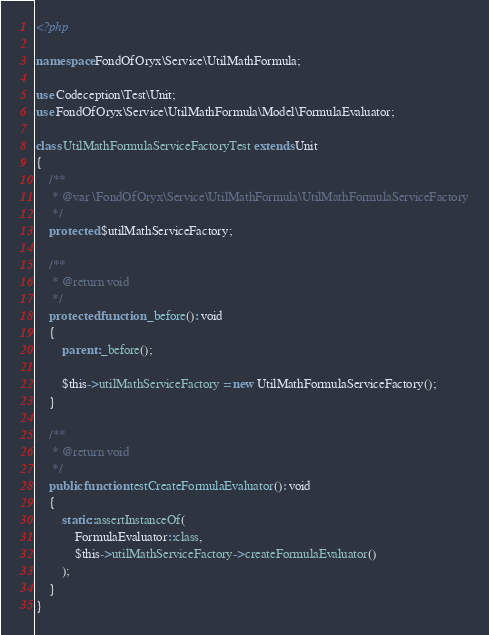Convert code to text. <code><loc_0><loc_0><loc_500><loc_500><_PHP_><?php

namespace FondOfOryx\Service\UtilMathFormula;

use Codeception\Test\Unit;
use FondOfOryx\Service\UtilMathFormula\Model\FormulaEvaluator;

class UtilMathFormulaServiceFactoryTest extends Unit
{
    /**
     * @var \FondOfOryx\Service\UtilMathFormula\UtilMathFormulaServiceFactory
     */
    protected $utilMathServiceFactory;

    /**
     * @return void
     */
    protected function _before(): void
    {
        parent::_before();

        $this->utilMathServiceFactory = new UtilMathFormulaServiceFactory();
    }

    /**
     * @return void
     */
    public function testCreateFormulaEvaluator(): void
    {
        static::assertInstanceOf(
            FormulaEvaluator::class,
            $this->utilMathServiceFactory->createFormulaEvaluator()
        );
    }
}
</code> 